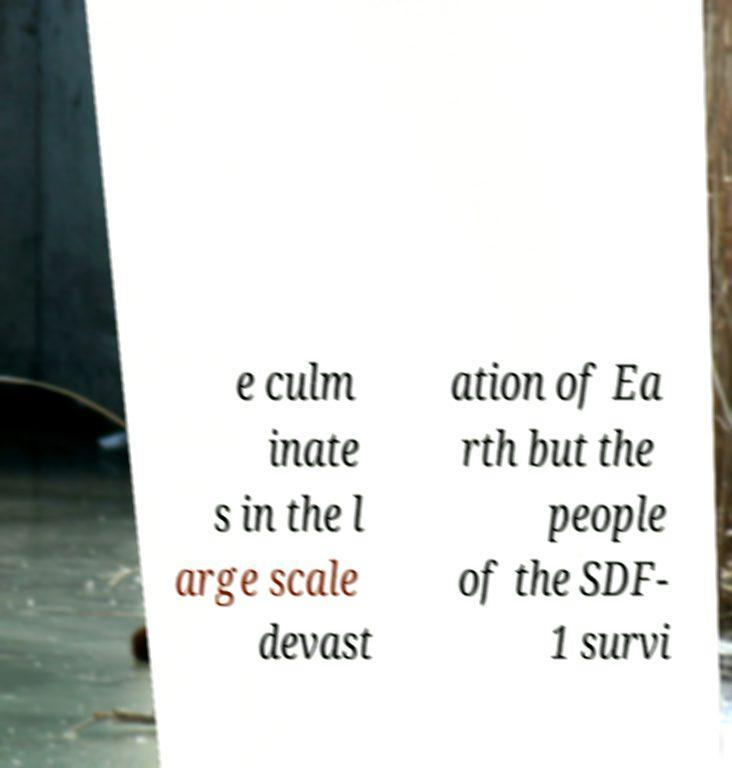For documentation purposes, I need the text within this image transcribed. Could you provide that? e culm inate s in the l arge scale devast ation of Ea rth but the people of the SDF- 1 survi 